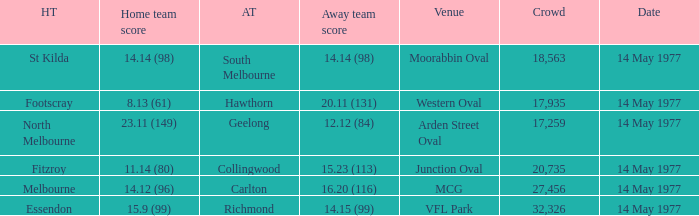I want to know the home team score of the away team of richmond that has a crowd more than 20,735 15.9 (99). 